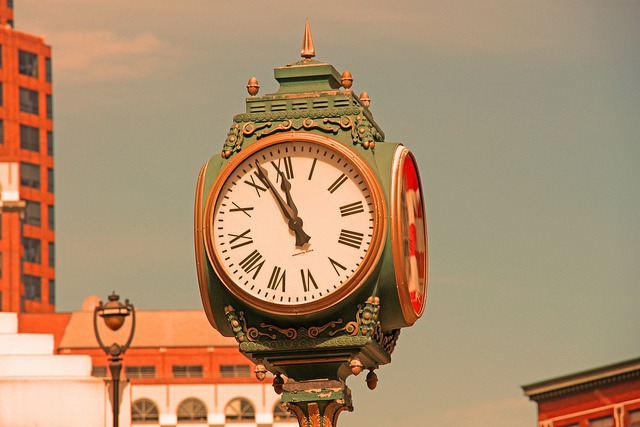Describe the objects in this image and their specific colors. I can see clock in red, tan, brown, maroon, and orange tones and clock in red, brown, and orange tones in this image. 